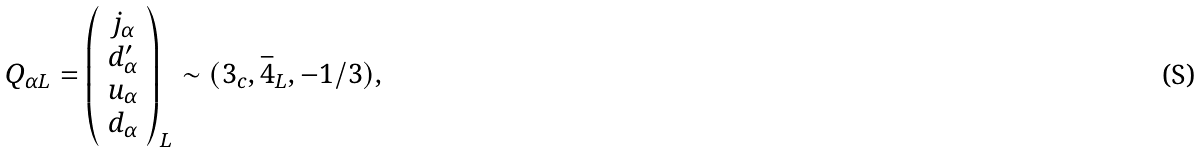<formula> <loc_0><loc_0><loc_500><loc_500>Q _ { \alpha L } = \left ( \begin{array} { c } j _ { \alpha } \\ d ^ { \prime } _ { \alpha } \\ u _ { \alpha } \\ d _ { \alpha } \end{array} \right ) _ { L } \sim ( { 3 } _ { c } , \bar { 4 } _ { L } , - 1 / 3 ) ,</formula> 